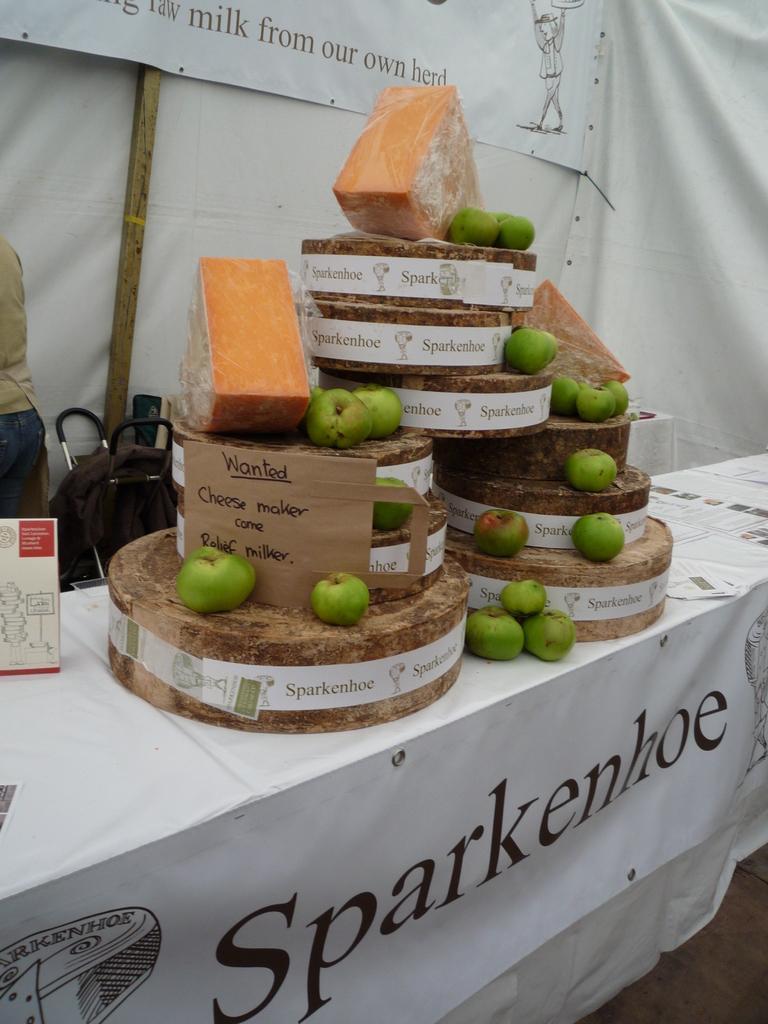How would you summarize this image in a sentence or two? In this image we can see a group of apples, cheese, papers and the boards with some text on them which are placed on a table. We can also see a banner with some text on it, a bag and a person standing. 